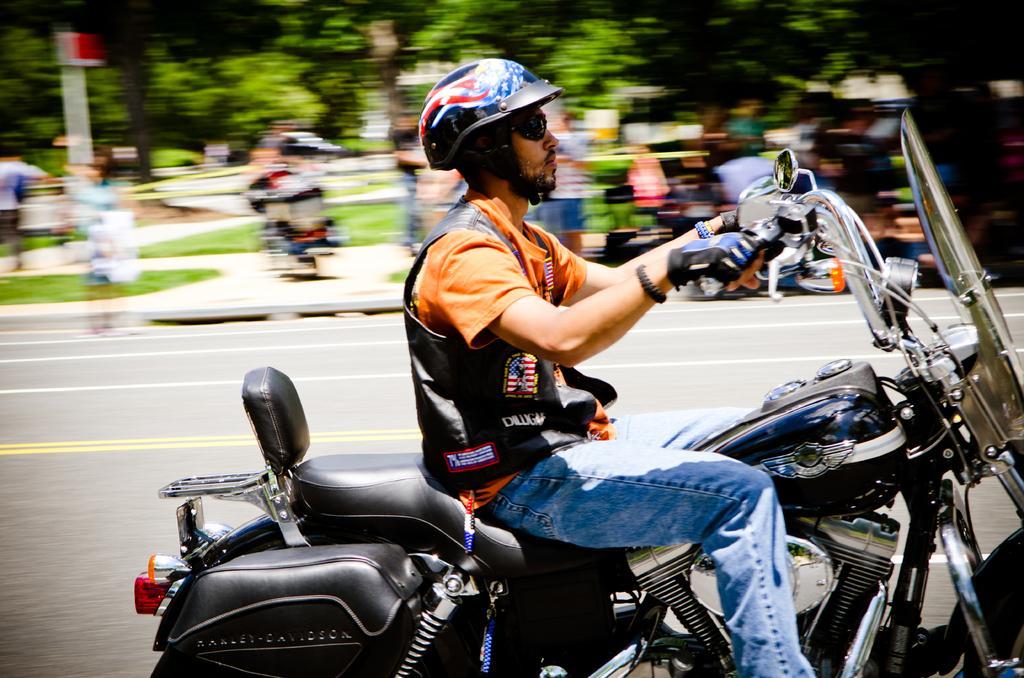In one or two sentences, can you explain what this image depicts? This is a picture consist of a man riding on the motor cycle ,wearing a helmet and wearing a spectacles ,background I can see there are the trees ,there is a road visible. 